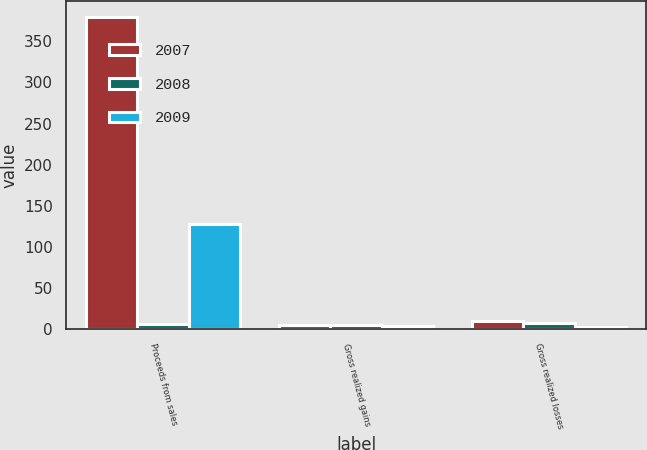Convert chart to OTSL. <chart><loc_0><loc_0><loc_500><loc_500><stacked_bar_chart><ecel><fcel>Proceeds from sales<fcel>Gross realized gains<fcel>Gross realized losses<nl><fcel>2007<fcel>380<fcel>5<fcel>10<nl><fcel>2008<fcel>6.5<fcel>5<fcel>8<nl><fcel>2009<fcel>128<fcel>4<fcel>3<nl></chart> 